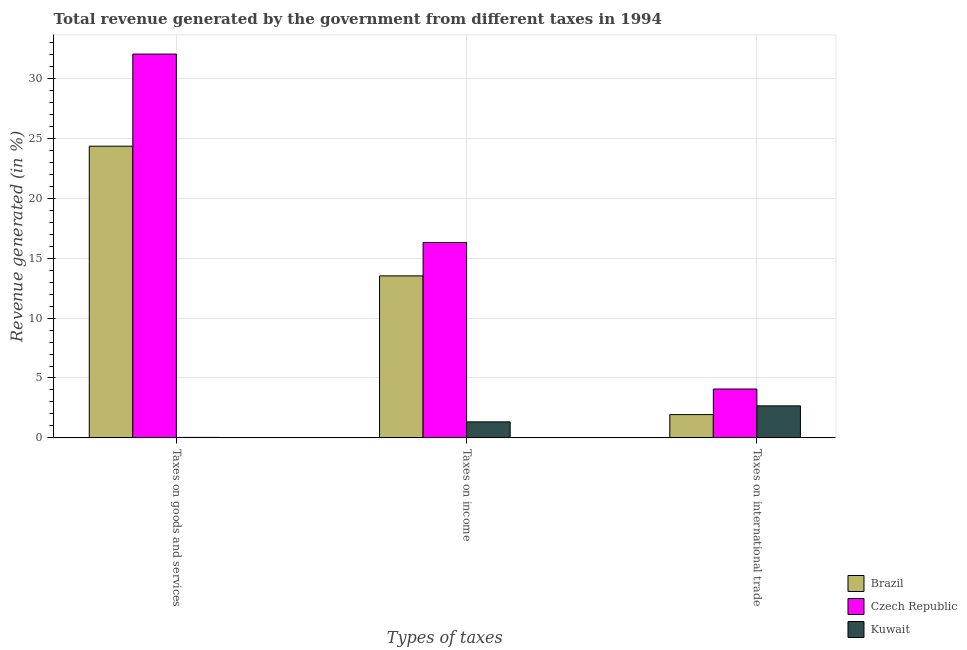How many different coloured bars are there?
Keep it short and to the point. 3. How many groups of bars are there?
Offer a very short reply. 3. How many bars are there on the 1st tick from the left?
Keep it short and to the point. 3. What is the label of the 1st group of bars from the left?
Provide a succinct answer. Taxes on goods and services. What is the percentage of revenue generated by taxes on income in Kuwait?
Your response must be concise. 1.34. Across all countries, what is the maximum percentage of revenue generated by taxes on income?
Your answer should be compact. 16.32. Across all countries, what is the minimum percentage of revenue generated by taxes on goods and services?
Provide a short and direct response. 0.04. In which country was the percentage of revenue generated by tax on international trade maximum?
Keep it short and to the point. Czech Republic. What is the total percentage of revenue generated by tax on international trade in the graph?
Ensure brevity in your answer.  8.7. What is the difference between the percentage of revenue generated by taxes on goods and services in Czech Republic and that in Brazil?
Ensure brevity in your answer.  7.69. What is the difference between the percentage of revenue generated by taxes on goods and services in Kuwait and the percentage of revenue generated by tax on international trade in Brazil?
Offer a terse response. -1.91. What is the average percentage of revenue generated by tax on international trade per country?
Keep it short and to the point. 2.9. What is the difference between the percentage of revenue generated by tax on international trade and percentage of revenue generated by taxes on income in Brazil?
Your response must be concise. -11.58. In how many countries, is the percentage of revenue generated by tax on international trade greater than 16 %?
Your answer should be compact. 0. What is the ratio of the percentage of revenue generated by taxes on goods and services in Czech Republic to that in Kuwait?
Provide a short and direct response. 815.7. Is the percentage of revenue generated by taxes on income in Czech Republic less than that in Brazil?
Make the answer very short. No. Is the difference between the percentage of revenue generated by taxes on goods and services in Brazil and Czech Republic greater than the difference between the percentage of revenue generated by tax on international trade in Brazil and Czech Republic?
Your answer should be compact. No. What is the difference between the highest and the second highest percentage of revenue generated by taxes on income?
Your response must be concise. 2.79. What is the difference between the highest and the lowest percentage of revenue generated by tax on international trade?
Your response must be concise. 2.13. In how many countries, is the percentage of revenue generated by taxes on goods and services greater than the average percentage of revenue generated by taxes on goods and services taken over all countries?
Your response must be concise. 2. Is the sum of the percentage of revenue generated by taxes on income in Brazil and Kuwait greater than the maximum percentage of revenue generated by taxes on goods and services across all countries?
Offer a terse response. No. What does the 2nd bar from the left in Taxes on international trade represents?
Keep it short and to the point. Czech Republic. What does the 2nd bar from the right in Taxes on income represents?
Provide a short and direct response. Czech Republic. How many bars are there?
Provide a short and direct response. 9. How many countries are there in the graph?
Make the answer very short. 3. Does the graph contain any zero values?
Offer a terse response. No. Does the graph contain grids?
Offer a very short reply. Yes. Where does the legend appear in the graph?
Provide a short and direct response. Bottom right. How are the legend labels stacked?
Offer a terse response. Vertical. What is the title of the graph?
Make the answer very short. Total revenue generated by the government from different taxes in 1994. What is the label or title of the X-axis?
Your answer should be compact. Types of taxes. What is the label or title of the Y-axis?
Give a very brief answer. Revenue generated (in %). What is the Revenue generated (in %) in Brazil in Taxes on goods and services?
Ensure brevity in your answer.  24.36. What is the Revenue generated (in %) in Czech Republic in Taxes on goods and services?
Give a very brief answer. 32.05. What is the Revenue generated (in %) of Kuwait in Taxes on goods and services?
Give a very brief answer. 0.04. What is the Revenue generated (in %) in Brazil in Taxes on income?
Offer a terse response. 13.53. What is the Revenue generated (in %) of Czech Republic in Taxes on income?
Ensure brevity in your answer.  16.32. What is the Revenue generated (in %) of Kuwait in Taxes on income?
Provide a short and direct response. 1.34. What is the Revenue generated (in %) in Brazil in Taxes on international trade?
Your response must be concise. 1.94. What is the Revenue generated (in %) of Czech Republic in Taxes on international trade?
Make the answer very short. 4.08. What is the Revenue generated (in %) in Kuwait in Taxes on international trade?
Your answer should be very brief. 2.67. Across all Types of taxes, what is the maximum Revenue generated (in %) of Brazil?
Make the answer very short. 24.36. Across all Types of taxes, what is the maximum Revenue generated (in %) of Czech Republic?
Ensure brevity in your answer.  32.05. Across all Types of taxes, what is the maximum Revenue generated (in %) in Kuwait?
Keep it short and to the point. 2.67. Across all Types of taxes, what is the minimum Revenue generated (in %) of Brazil?
Provide a short and direct response. 1.94. Across all Types of taxes, what is the minimum Revenue generated (in %) in Czech Republic?
Give a very brief answer. 4.08. Across all Types of taxes, what is the minimum Revenue generated (in %) in Kuwait?
Make the answer very short. 0.04. What is the total Revenue generated (in %) of Brazil in the graph?
Give a very brief answer. 39.83. What is the total Revenue generated (in %) of Czech Republic in the graph?
Your response must be concise. 52.45. What is the total Revenue generated (in %) of Kuwait in the graph?
Your answer should be compact. 4.05. What is the difference between the Revenue generated (in %) of Brazil in Taxes on goods and services and that in Taxes on income?
Provide a succinct answer. 10.83. What is the difference between the Revenue generated (in %) in Czech Republic in Taxes on goods and services and that in Taxes on income?
Your answer should be compact. 15.74. What is the difference between the Revenue generated (in %) in Kuwait in Taxes on goods and services and that in Taxes on income?
Ensure brevity in your answer.  -1.3. What is the difference between the Revenue generated (in %) in Brazil in Taxes on goods and services and that in Taxes on international trade?
Provide a short and direct response. 22.41. What is the difference between the Revenue generated (in %) in Czech Republic in Taxes on goods and services and that in Taxes on international trade?
Provide a succinct answer. 27.97. What is the difference between the Revenue generated (in %) of Kuwait in Taxes on goods and services and that in Taxes on international trade?
Give a very brief answer. -2.63. What is the difference between the Revenue generated (in %) in Brazil in Taxes on income and that in Taxes on international trade?
Your answer should be very brief. 11.58. What is the difference between the Revenue generated (in %) in Czech Republic in Taxes on income and that in Taxes on international trade?
Offer a terse response. 12.24. What is the difference between the Revenue generated (in %) of Kuwait in Taxes on income and that in Taxes on international trade?
Provide a succinct answer. -1.34. What is the difference between the Revenue generated (in %) in Brazil in Taxes on goods and services and the Revenue generated (in %) in Czech Republic in Taxes on income?
Your response must be concise. 8.04. What is the difference between the Revenue generated (in %) in Brazil in Taxes on goods and services and the Revenue generated (in %) in Kuwait in Taxes on income?
Your answer should be very brief. 23.02. What is the difference between the Revenue generated (in %) of Czech Republic in Taxes on goods and services and the Revenue generated (in %) of Kuwait in Taxes on income?
Your answer should be compact. 30.71. What is the difference between the Revenue generated (in %) in Brazil in Taxes on goods and services and the Revenue generated (in %) in Czech Republic in Taxes on international trade?
Provide a short and direct response. 20.28. What is the difference between the Revenue generated (in %) of Brazil in Taxes on goods and services and the Revenue generated (in %) of Kuwait in Taxes on international trade?
Make the answer very short. 21.69. What is the difference between the Revenue generated (in %) in Czech Republic in Taxes on goods and services and the Revenue generated (in %) in Kuwait in Taxes on international trade?
Offer a terse response. 29.38. What is the difference between the Revenue generated (in %) of Brazil in Taxes on income and the Revenue generated (in %) of Czech Republic in Taxes on international trade?
Keep it short and to the point. 9.45. What is the difference between the Revenue generated (in %) of Brazil in Taxes on income and the Revenue generated (in %) of Kuwait in Taxes on international trade?
Your answer should be very brief. 10.86. What is the difference between the Revenue generated (in %) in Czech Republic in Taxes on income and the Revenue generated (in %) in Kuwait in Taxes on international trade?
Keep it short and to the point. 13.64. What is the average Revenue generated (in %) in Brazil per Types of taxes?
Your response must be concise. 13.28. What is the average Revenue generated (in %) of Czech Republic per Types of taxes?
Your response must be concise. 17.48. What is the average Revenue generated (in %) in Kuwait per Types of taxes?
Offer a very short reply. 1.35. What is the difference between the Revenue generated (in %) of Brazil and Revenue generated (in %) of Czech Republic in Taxes on goods and services?
Give a very brief answer. -7.69. What is the difference between the Revenue generated (in %) of Brazil and Revenue generated (in %) of Kuwait in Taxes on goods and services?
Ensure brevity in your answer.  24.32. What is the difference between the Revenue generated (in %) in Czech Republic and Revenue generated (in %) in Kuwait in Taxes on goods and services?
Give a very brief answer. 32.01. What is the difference between the Revenue generated (in %) in Brazil and Revenue generated (in %) in Czech Republic in Taxes on income?
Your answer should be compact. -2.79. What is the difference between the Revenue generated (in %) in Brazil and Revenue generated (in %) in Kuwait in Taxes on income?
Your answer should be very brief. 12.19. What is the difference between the Revenue generated (in %) of Czech Republic and Revenue generated (in %) of Kuwait in Taxes on income?
Give a very brief answer. 14.98. What is the difference between the Revenue generated (in %) of Brazil and Revenue generated (in %) of Czech Republic in Taxes on international trade?
Offer a very short reply. -2.13. What is the difference between the Revenue generated (in %) in Brazil and Revenue generated (in %) in Kuwait in Taxes on international trade?
Keep it short and to the point. -0.73. What is the difference between the Revenue generated (in %) in Czech Republic and Revenue generated (in %) in Kuwait in Taxes on international trade?
Give a very brief answer. 1.41. What is the ratio of the Revenue generated (in %) in Brazil in Taxes on goods and services to that in Taxes on income?
Offer a very short reply. 1.8. What is the ratio of the Revenue generated (in %) of Czech Republic in Taxes on goods and services to that in Taxes on income?
Make the answer very short. 1.96. What is the ratio of the Revenue generated (in %) in Kuwait in Taxes on goods and services to that in Taxes on income?
Make the answer very short. 0.03. What is the ratio of the Revenue generated (in %) in Brazil in Taxes on goods and services to that in Taxes on international trade?
Provide a succinct answer. 12.53. What is the ratio of the Revenue generated (in %) in Czech Republic in Taxes on goods and services to that in Taxes on international trade?
Give a very brief answer. 7.86. What is the ratio of the Revenue generated (in %) of Kuwait in Taxes on goods and services to that in Taxes on international trade?
Your answer should be compact. 0.01. What is the ratio of the Revenue generated (in %) in Brazil in Taxes on income to that in Taxes on international trade?
Give a very brief answer. 6.96. What is the ratio of the Revenue generated (in %) of Czech Republic in Taxes on income to that in Taxes on international trade?
Give a very brief answer. 4. What is the ratio of the Revenue generated (in %) of Kuwait in Taxes on income to that in Taxes on international trade?
Your response must be concise. 0.5. What is the difference between the highest and the second highest Revenue generated (in %) of Brazil?
Ensure brevity in your answer.  10.83. What is the difference between the highest and the second highest Revenue generated (in %) of Czech Republic?
Ensure brevity in your answer.  15.74. What is the difference between the highest and the second highest Revenue generated (in %) of Kuwait?
Give a very brief answer. 1.34. What is the difference between the highest and the lowest Revenue generated (in %) of Brazil?
Provide a succinct answer. 22.41. What is the difference between the highest and the lowest Revenue generated (in %) in Czech Republic?
Your answer should be compact. 27.97. What is the difference between the highest and the lowest Revenue generated (in %) of Kuwait?
Offer a terse response. 2.63. 